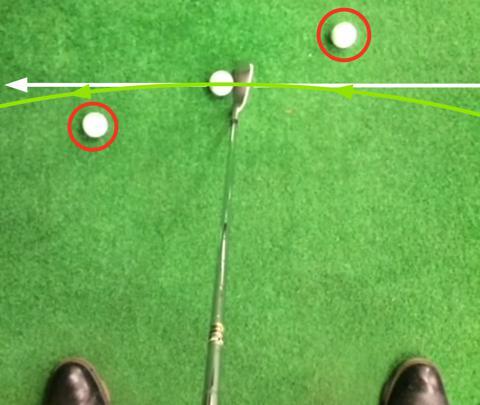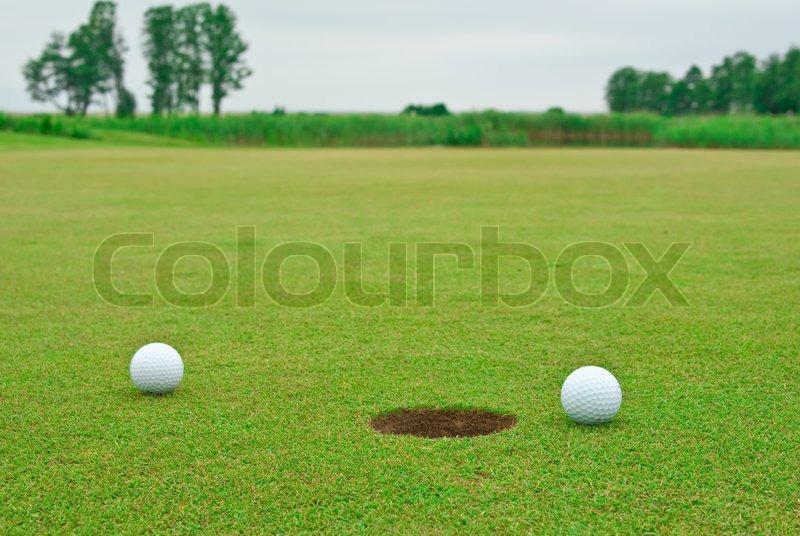The first image is the image on the left, the second image is the image on the right. Considering the images on both sides, is "There is at least two golf balls in the left image." valid? Answer yes or no. Yes. The first image is the image on the left, the second image is the image on the right. Examine the images to the left and right. Is the description "A golf ball is within a ball's-width of a hole with no flag in it." accurate? Answer yes or no. Yes. 